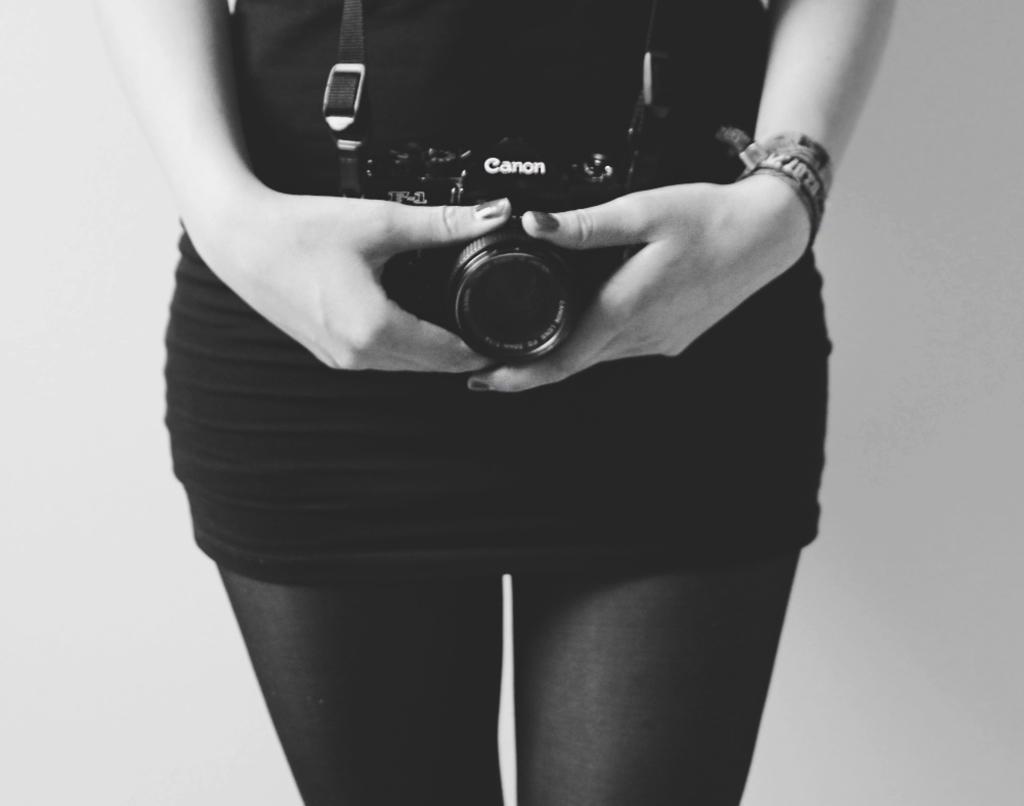How would you summarize this image in a sentence or two? Here in this picture we can see a woman in a black colored dress standing over a place and she is holding a camera in her hand. 